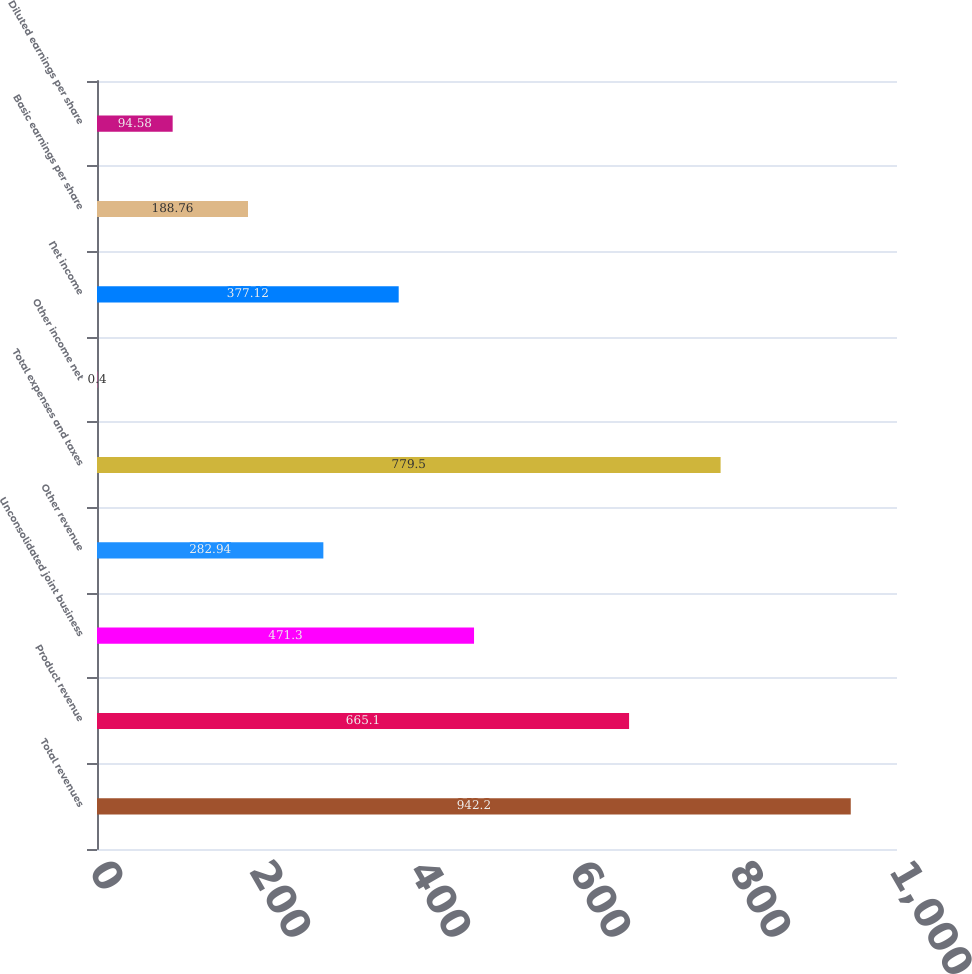Convert chart to OTSL. <chart><loc_0><loc_0><loc_500><loc_500><bar_chart><fcel>Total revenues<fcel>Product revenue<fcel>Unconsolidated joint business<fcel>Other revenue<fcel>Total expenses and taxes<fcel>Other income net<fcel>Net income<fcel>Basic earnings per share<fcel>Diluted earnings per share<nl><fcel>942.2<fcel>665.1<fcel>471.3<fcel>282.94<fcel>779.5<fcel>0.4<fcel>377.12<fcel>188.76<fcel>94.58<nl></chart> 